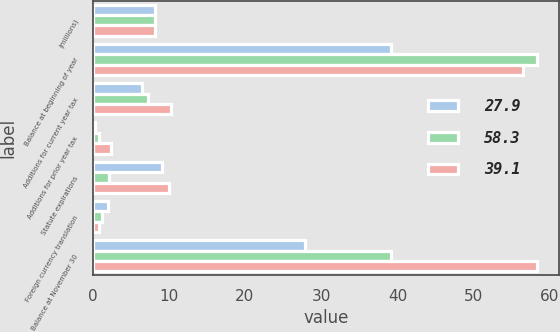Convert chart. <chart><loc_0><loc_0><loc_500><loc_500><stacked_bar_chart><ecel><fcel>(millions)<fcel>Balance at beginning of year<fcel>Additions for current year tax<fcel>Additions for prior year tax<fcel>Statute expirations<fcel>Foreign currency translation<fcel>Balance at November 30<nl><fcel>27.9<fcel>8.2<fcel>39.1<fcel>6.5<fcel>0.3<fcel>9.1<fcel>2<fcel>27.9<nl><fcel>58.3<fcel>8.2<fcel>58.3<fcel>7.3<fcel>0.9<fcel>2.1<fcel>1.2<fcel>39.1<nl><fcel>39.1<fcel>8.2<fcel>56.5<fcel>10.3<fcel>2.4<fcel>10<fcel>0.9<fcel>58.3<nl></chart> 